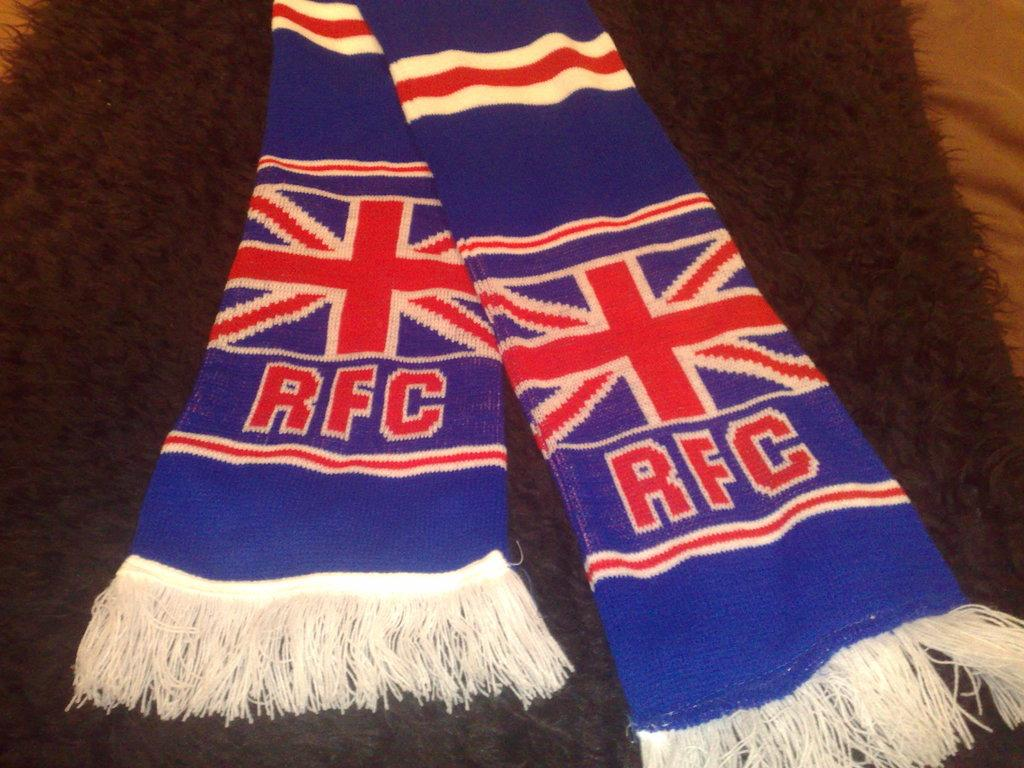<image>
Present a compact description of the photo's key features. A blue RFC scarf sitting on a darkly colored carpet. 